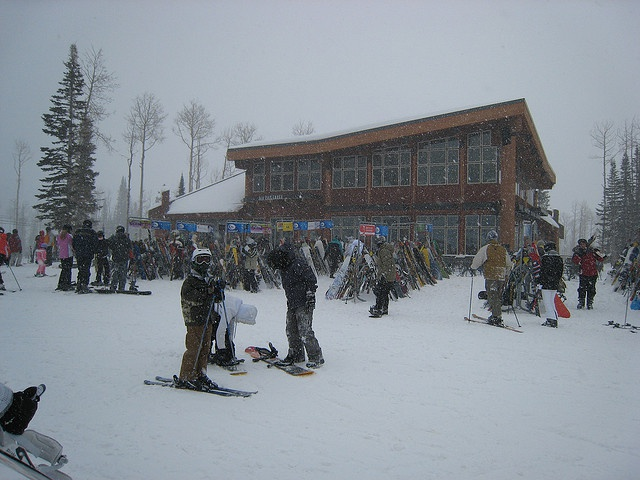Describe the objects in this image and their specific colors. I can see people in darkgray, gray, and black tones, people in gray, black, and darkgray tones, people in gray and black tones, people in gray, black, and darkgray tones, and people in gray, black, and darkgray tones in this image. 